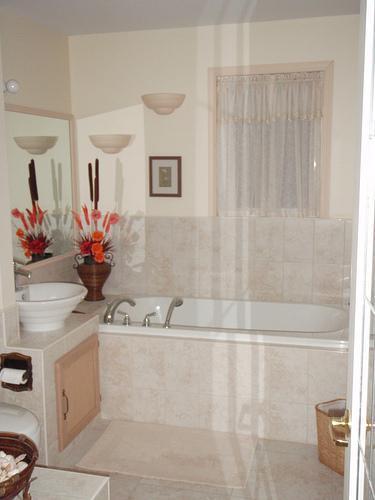How many sinks are there?
Give a very brief answer. 1. 